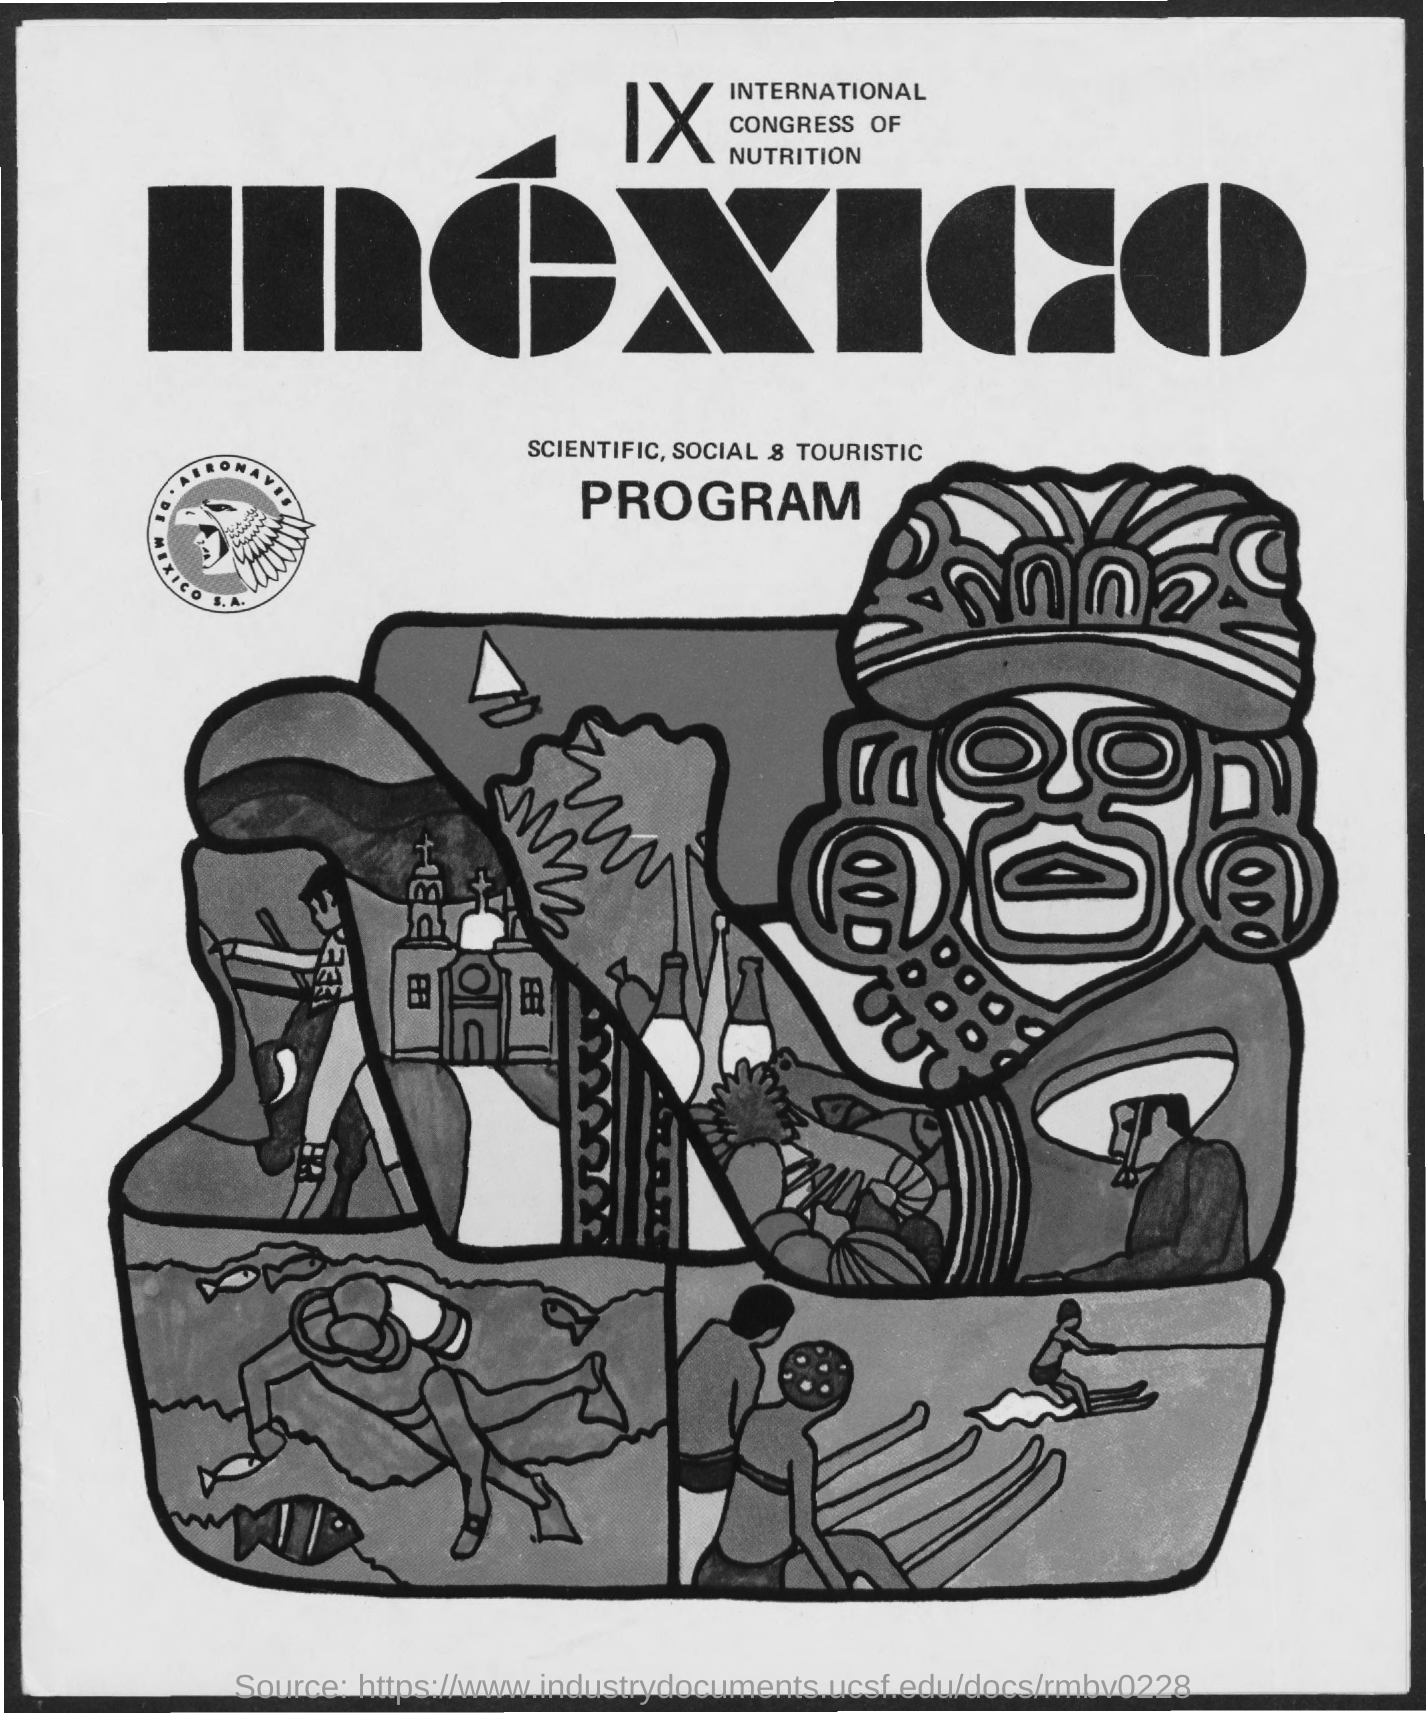Indicate a few pertinent items in this graphic. The 9th International Congress of Nutrition is scheduled to take place in Mexico. 